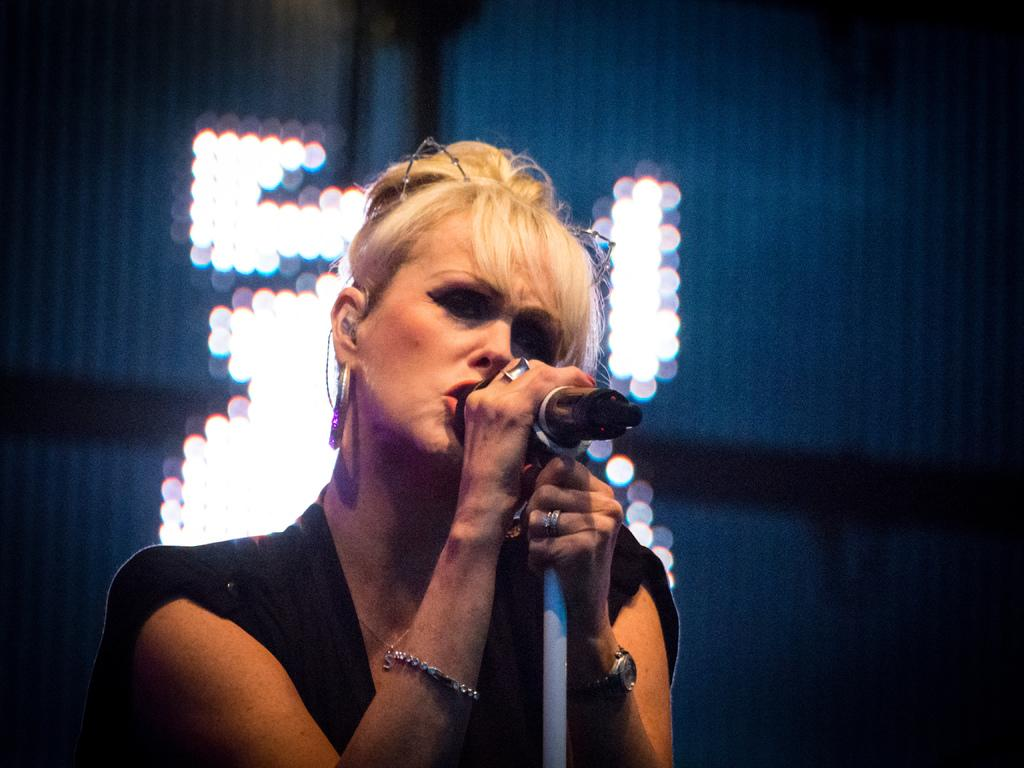Who is the main subject in the image? There is a lady in the image. What is the lady holding in her hands? The lady is holding a pole and a microphone. Can you describe the background of the image? The background of the image is blurred, but there are lights visible. What type of needle is the lady using to sew in the image? There is no needle present in the image; the lady is holding a pole and a microphone. How can we tell that the lady's father is present in the image? There is no mention of the lady's father in the image or the provided facts. 